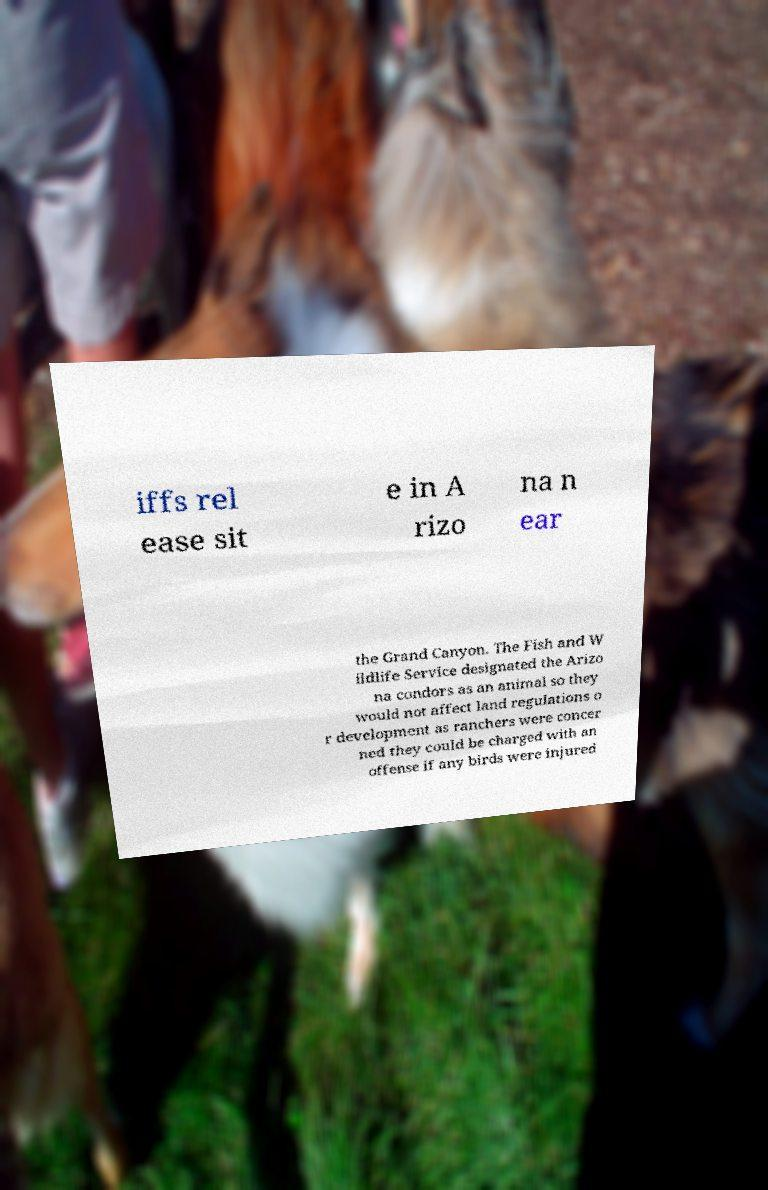Please read and relay the text visible in this image. What does it say? iffs rel ease sit e in A rizo na n ear the Grand Canyon. The Fish and W ildlife Service designated the Arizo na condors as an animal so they would not affect land regulations o r development as ranchers were concer ned they could be charged with an offense if any birds were injured 